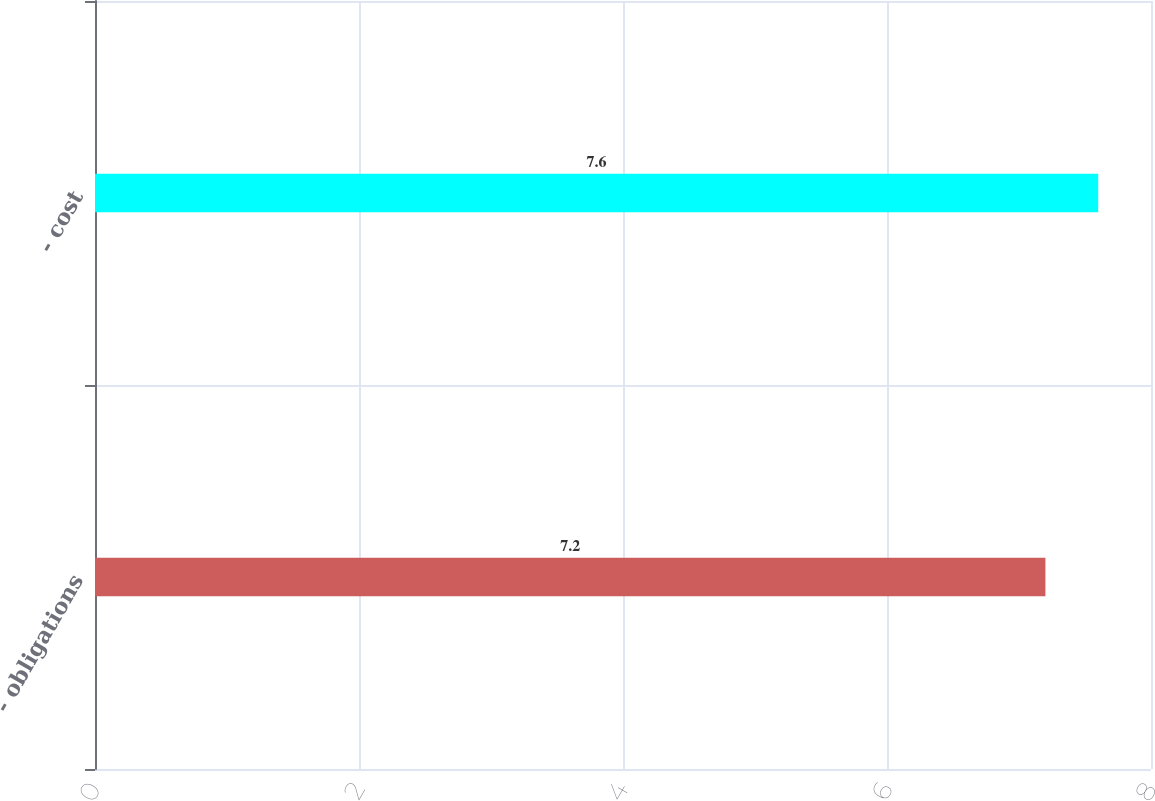Convert chart to OTSL. <chart><loc_0><loc_0><loc_500><loc_500><bar_chart><fcel>- obligations<fcel>- cost<nl><fcel>7.2<fcel>7.6<nl></chart> 